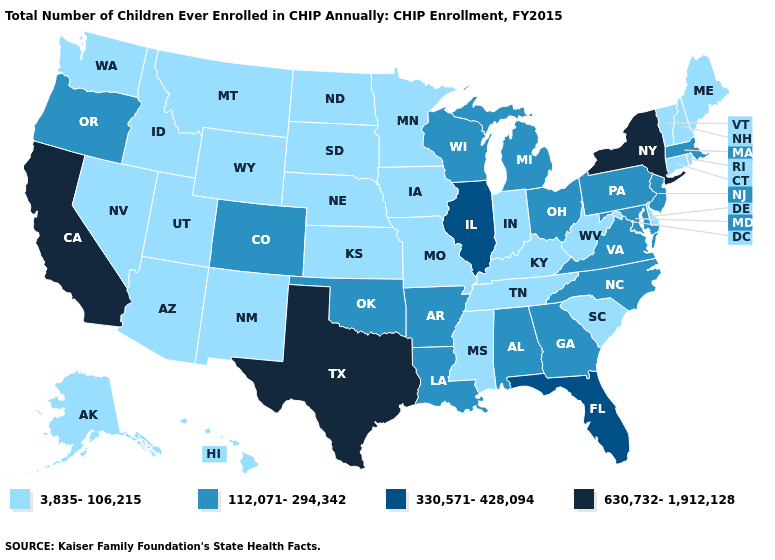Name the states that have a value in the range 330,571-428,094?
Be succinct. Florida, Illinois. What is the value of Missouri?
Write a very short answer. 3,835-106,215. What is the highest value in states that border South Dakota?
Short answer required. 3,835-106,215. Name the states that have a value in the range 330,571-428,094?
Answer briefly. Florida, Illinois. Does the first symbol in the legend represent the smallest category?
Give a very brief answer. Yes. What is the value of Delaware?
Concise answer only. 3,835-106,215. Is the legend a continuous bar?
Quick response, please. No. Among the states that border Connecticut , which have the highest value?
Short answer required. New York. Does South Carolina have the highest value in the USA?
Quick response, please. No. Name the states that have a value in the range 3,835-106,215?
Be succinct. Alaska, Arizona, Connecticut, Delaware, Hawaii, Idaho, Indiana, Iowa, Kansas, Kentucky, Maine, Minnesota, Mississippi, Missouri, Montana, Nebraska, Nevada, New Hampshire, New Mexico, North Dakota, Rhode Island, South Carolina, South Dakota, Tennessee, Utah, Vermont, Washington, West Virginia, Wyoming. Name the states that have a value in the range 630,732-1,912,128?
Be succinct. California, New York, Texas. What is the lowest value in the South?
Concise answer only. 3,835-106,215. Which states have the highest value in the USA?
Quick response, please. California, New York, Texas. Name the states that have a value in the range 330,571-428,094?
Concise answer only. Florida, Illinois. Does Texas have the highest value in the USA?
Concise answer only. Yes. 